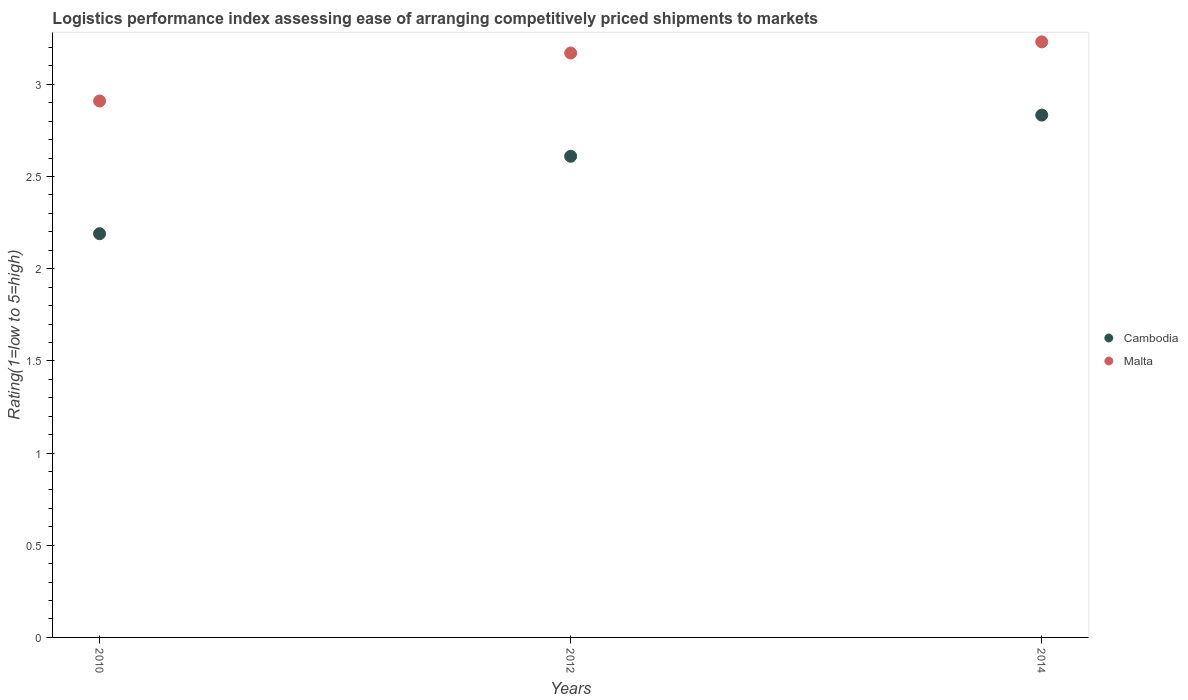How many different coloured dotlines are there?
Give a very brief answer. 2. Is the number of dotlines equal to the number of legend labels?
Keep it short and to the point. Yes. What is the Logistic performance index in Malta in 2014?
Your answer should be very brief. 3.23. Across all years, what is the maximum Logistic performance index in Cambodia?
Provide a short and direct response. 2.83. Across all years, what is the minimum Logistic performance index in Malta?
Make the answer very short. 2.91. What is the total Logistic performance index in Malta in the graph?
Ensure brevity in your answer.  9.31. What is the difference between the Logistic performance index in Malta in 2010 and that in 2014?
Your answer should be very brief. -0.32. What is the difference between the Logistic performance index in Cambodia in 2010 and the Logistic performance index in Malta in 2012?
Ensure brevity in your answer.  -0.98. What is the average Logistic performance index in Malta per year?
Your response must be concise. 3.1. In the year 2012, what is the difference between the Logistic performance index in Malta and Logistic performance index in Cambodia?
Keep it short and to the point. 0.56. In how many years, is the Logistic performance index in Malta greater than 2.6?
Your answer should be compact. 3. What is the ratio of the Logistic performance index in Cambodia in 2012 to that in 2014?
Provide a short and direct response. 0.92. Is the Logistic performance index in Malta in 2010 less than that in 2014?
Your answer should be compact. Yes. Is the difference between the Logistic performance index in Malta in 2010 and 2012 greater than the difference between the Logistic performance index in Cambodia in 2010 and 2012?
Keep it short and to the point. Yes. What is the difference between the highest and the second highest Logistic performance index in Cambodia?
Give a very brief answer. 0.22. What is the difference between the highest and the lowest Logistic performance index in Cambodia?
Your answer should be very brief. 0.64. In how many years, is the Logistic performance index in Malta greater than the average Logistic performance index in Malta taken over all years?
Your response must be concise. 2. Does the Logistic performance index in Malta monotonically increase over the years?
Your response must be concise. Yes. Is the Logistic performance index in Cambodia strictly greater than the Logistic performance index in Malta over the years?
Provide a succinct answer. No. How many dotlines are there?
Your answer should be very brief. 2. How many years are there in the graph?
Keep it short and to the point. 3. Does the graph contain any zero values?
Your response must be concise. No. How many legend labels are there?
Make the answer very short. 2. How are the legend labels stacked?
Your response must be concise. Vertical. What is the title of the graph?
Keep it short and to the point. Logistics performance index assessing ease of arranging competitively priced shipments to markets. What is the label or title of the X-axis?
Your answer should be very brief. Years. What is the label or title of the Y-axis?
Provide a short and direct response. Rating(1=low to 5=high). What is the Rating(1=low to 5=high) in Cambodia in 2010?
Keep it short and to the point. 2.19. What is the Rating(1=low to 5=high) of Malta in 2010?
Offer a terse response. 2.91. What is the Rating(1=low to 5=high) of Cambodia in 2012?
Ensure brevity in your answer.  2.61. What is the Rating(1=low to 5=high) of Malta in 2012?
Keep it short and to the point. 3.17. What is the Rating(1=low to 5=high) of Cambodia in 2014?
Offer a very short reply. 2.83. What is the Rating(1=low to 5=high) of Malta in 2014?
Your response must be concise. 3.23. Across all years, what is the maximum Rating(1=low to 5=high) of Cambodia?
Your response must be concise. 2.83. Across all years, what is the maximum Rating(1=low to 5=high) in Malta?
Offer a very short reply. 3.23. Across all years, what is the minimum Rating(1=low to 5=high) of Cambodia?
Provide a succinct answer. 2.19. Across all years, what is the minimum Rating(1=low to 5=high) of Malta?
Keep it short and to the point. 2.91. What is the total Rating(1=low to 5=high) of Cambodia in the graph?
Make the answer very short. 7.63. What is the total Rating(1=low to 5=high) in Malta in the graph?
Give a very brief answer. 9.31. What is the difference between the Rating(1=low to 5=high) in Cambodia in 2010 and that in 2012?
Your response must be concise. -0.42. What is the difference between the Rating(1=low to 5=high) of Malta in 2010 and that in 2012?
Provide a succinct answer. -0.26. What is the difference between the Rating(1=low to 5=high) of Cambodia in 2010 and that in 2014?
Offer a very short reply. -0.64. What is the difference between the Rating(1=low to 5=high) of Malta in 2010 and that in 2014?
Keep it short and to the point. -0.32. What is the difference between the Rating(1=low to 5=high) of Cambodia in 2012 and that in 2014?
Offer a terse response. -0.22. What is the difference between the Rating(1=low to 5=high) in Malta in 2012 and that in 2014?
Your answer should be very brief. -0.06. What is the difference between the Rating(1=low to 5=high) of Cambodia in 2010 and the Rating(1=low to 5=high) of Malta in 2012?
Keep it short and to the point. -0.98. What is the difference between the Rating(1=low to 5=high) of Cambodia in 2010 and the Rating(1=low to 5=high) of Malta in 2014?
Give a very brief answer. -1.04. What is the difference between the Rating(1=low to 5=high) of Cambodia in 2012 and the Rating(1=low to 5=high) of Malta in 2014?
Offer a terse response. -0.62. What is the average Rating(1=low to 5=high) in Cambodia per year?
Offer a terse response. 2.54. What is the average Rating(1=low to 5=high) in Malta per year?
Your answer should be compact. 3.1. In the year 2010, what is the difference between the Rating(1=low to 5=high) of Cambodia and Rating(1=low to 5=high) of Malta?
Keep it short and to the point. -0.72. In the year 2012, what is the difference between the Rating(1=low to 5=high) of Cambodia and Rating(1=low to 5=high) of Malta?
Offer a terse response. -0.56. In the year 2014, what is the difference between the Rating(1=low to 5=high) of Cambodia and Rating(1=low to 5=high) of Malta?
Ensure brevity in your answer.  -0.4. What is the ratio of the Rating(1=low to 5=high) of Cambodia in 2010 to that in 2012?
Offer a terse response. 0.84. What is the ratio of the Rating(1=low to 5=high) of Malta in 2010 to that in 2012?
Ensure brevity in your answer.  0.92. What is the ratio of the Rating(1=low to 5=high) in Cambodia in 2010 to that in 2014?
Make the answer very short. 0.77. What is the ratio of the Rating(1=low to 5=high) in Malta in 2010 to that in 2014?
Your response must be concise. 0.9. What is the ratio of the Rating(1=low to 5=high) of Cambodia in 2012 to that in 2014?
Make the answer very short. 0.92. What is the ratio of the Rating(1=low to 5=high) of Malta in 2012 to that in 2014?
Ensure brevity in your answer.  0.98. What is the difference between the highest and the second highest Rating(1=low to 5=high) in Cambodia?
Provide a short and direct response. 0.22. What is the difference between the highest and the second highest Rating(1=low to 5=high) in Malta?
Your answer should be very brief. 0.06. What is the difference between the highest and the lowest Rating(1=low to 5=high) of Cambodia?
Provide a short and direct response. 0.64. What is the difference between the highest and the lowest Rating(1=low to 5=high) in Malta?
Provide a short and direct response. 0.32. 